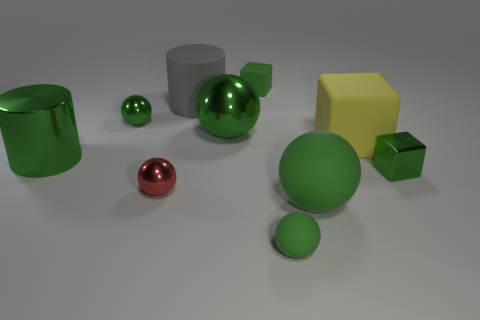How many green spheres must be subtracted to get 2 green spheres? 2 Subtract all yellow cylinders. How many green spheres are left? 4 Subtract 1 balls. How many balls are left? 4 Subtract all green spheres. Subtract all green cylinders. How many spheres are left? 1 Subtract all cylinders. How many objects are left? 8 Add 9 large gray rubber objects. How many large gray rubber objects are left? 10 Add 1 green shiny spheres. How many green shiny spheres exist? 3 Subtract 0 brown balls. How many objects are left? 10 Subtract all large green metal spheres. Subtract all big cubes. How many objects are left? 8 